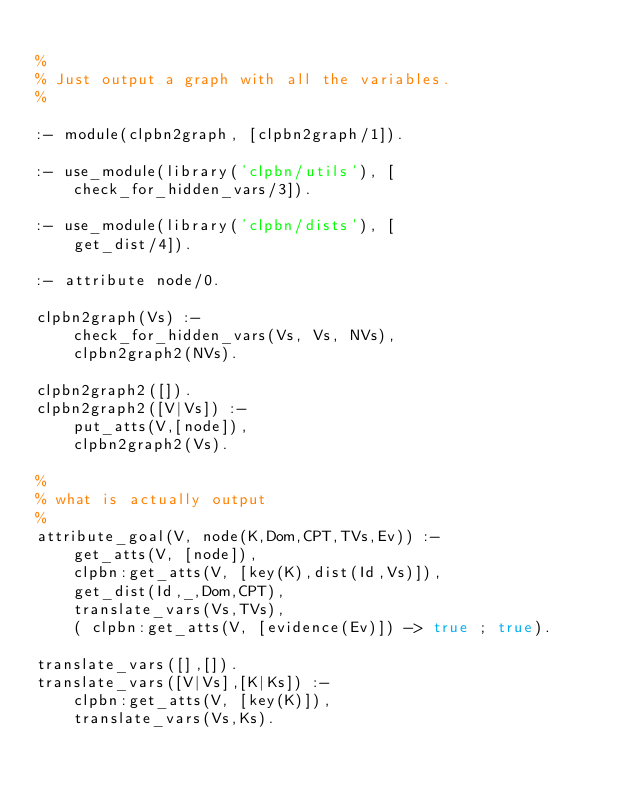<code> <loc_0><loc_0><loc_500><loc_500><_Prolog_>
%
% Just output a graph with all the variables.
%

:- module(clpbn2graph, [clpbn2graph/1]).

:- use_module(library('clpbn/utils'), [
	check_for_hidden_vars/3]).

:- use_module(library('clpbn/dists'), [
	get_dist/4]).

:- attribute node/0.

clpbn2graph(Vs) :-
	check_for_hidden_vars(Vs, Vs, NVs),
	clpbn2graph2(NVs).

clpbn2graph2([]).
clpbn2graph2([V|Vs]) :-
	put_atts(V,[node]),
	clpbn2graph2(Vs).

%
% what is actually output
%
attribute_goal(V, node(K,Dom,CPT,TVs,Ev)) :-
	get_atts(V, [node]),
	clpbn:get_atts(V, [key(K),dist(Id,Vs)]),
	get_dist(Id,_,Dom,CPT),
	translate_vars(Vs,TVs),
	( clpbn:get_atts(V, [evidence(Ev)]) -> true ; true).

translate_vars([],[]).
translate_vars([V|Vs],[K|Ks]) :-
	clpbn:get_atts(V, [key(K)]),
	translate_vars(Vs,Ks).





</code> 